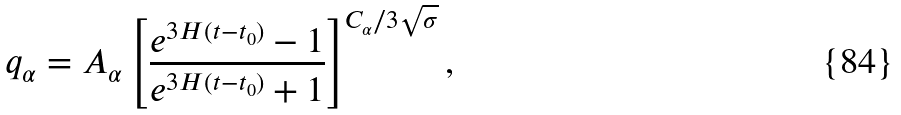<formula> <loc_0><loc_0><loc_500><loc_500>q _ { \alpha } = A _ { \alpha } \left [ \frac { e ^ { 3 H ( t - t _ { 0 } ) } - 1 } { e ^ { 3 H ( t - t _ { 0 } ) } + 1 } \right ] ^ { C _ { \alpha } / 3 \sqrt { \sigma } } ,</formula> 